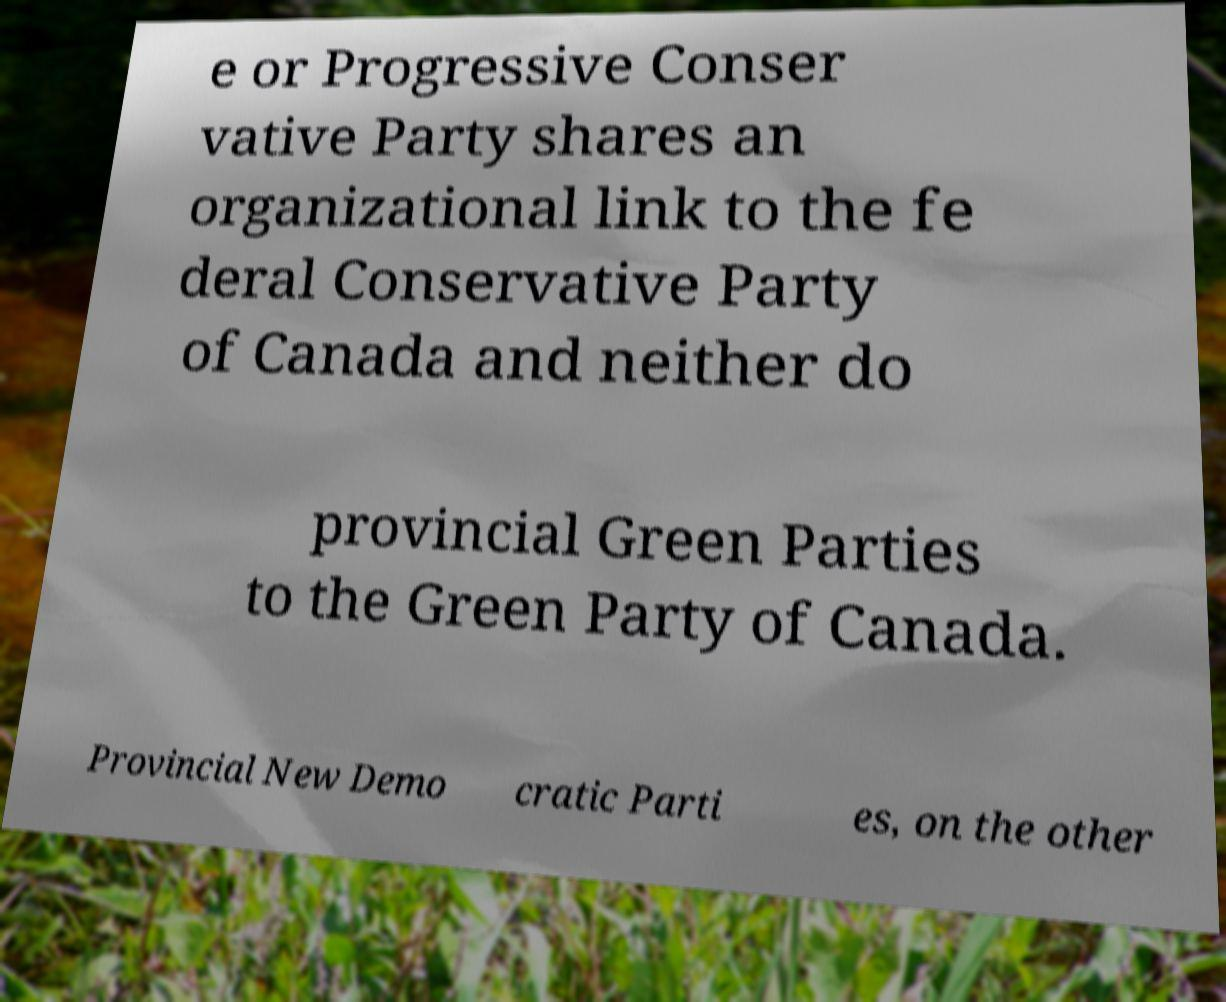Can you accurately transcribe the text from the provided image for me? e or Progressive Conser vative Party shares an organizational link to the fe deral Conservative Party of Canada and neither do provincial Green Parties to the Green Party of Canada. Provincial New Demo cratic Parti es, on the other 